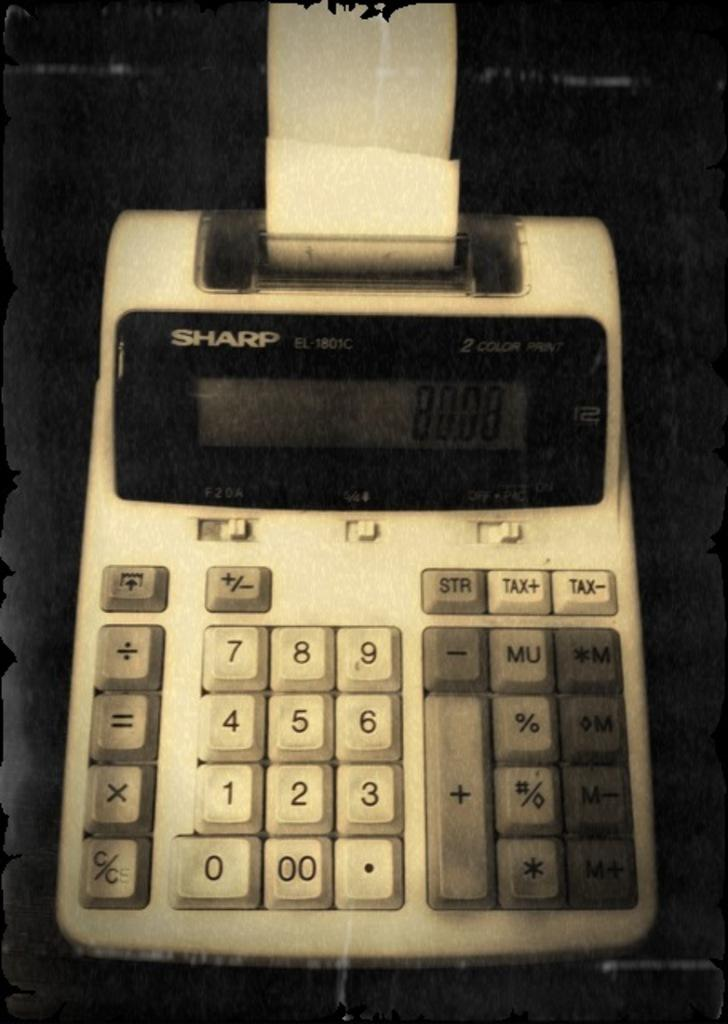Provide a one-sentence caption for the provided image. a Sharp calculating device with many numbers on it. 